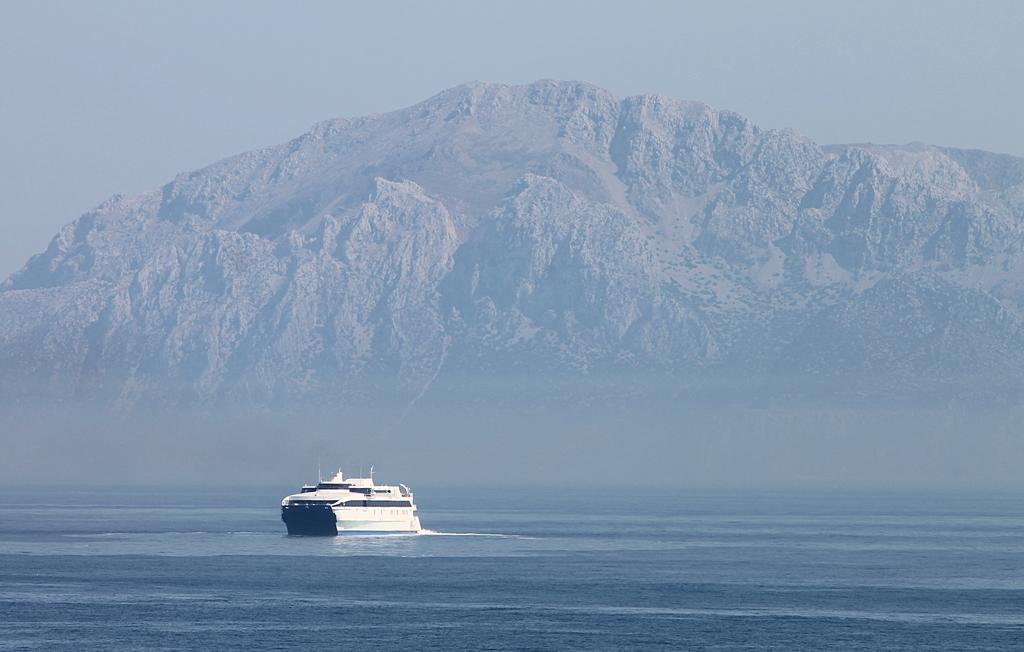What is the main subject of the image? There is a ship in the image. Can you describe the ship's appearance? The ship is white. What color is the water surrounding the ship? The water is blue. What can be seen in the background of the image? There is a mountain and the sky visible in the background. What type of apparatus is being used to measure the depth of the water in the image? There is no apparatus visible in the image for measuring the depth of the water. Can you see the nose of the ship in the image? Ships do not have noses like animals; they have bows, which are not mentioned in the image. 